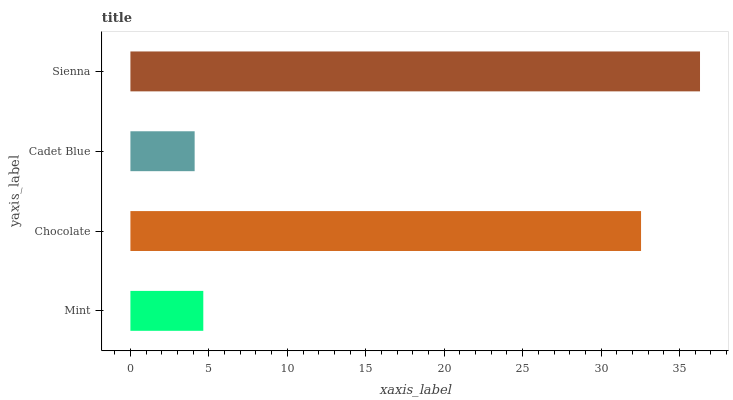Is Cadet Blue the minimum?
Answer yes or no. Yes. Is Sienna the maximum?
Answer yes or no. Yes. Is Chocolate the minimum?
Answer yes or no. No. Is Chocolate the maximum?
Answer yes or no. No. Is Chocolate greater than Mint?
Answer yes or no. Yes. Is Mint less than Chocolate?
Answer yes or no. Yes. Is Mint greater than Chocolate?
Answer yes or no. No. Is Chocolate less than Mint?
Answer yes or no. No. Is Chocolate the high median?
Answer yes or no. Yes. Is Mint the low median?
Answer yes or no. Yes. Is Sienna the high median?
Answer yes or no. No. Is Chocolate the low median?
Answer yes or no. No. 